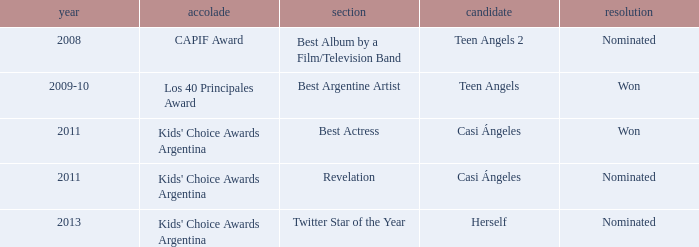What was the nomination category for herself? Twitter Star of the Year. 